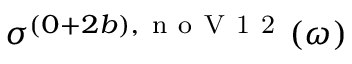Convert formula to latex. <formula><loc_0><loc_0><loc_500><loc_500>\sigma ^ { ( 0 + 2 b ) , n o V 1 2 } ( \omega )</formula> 